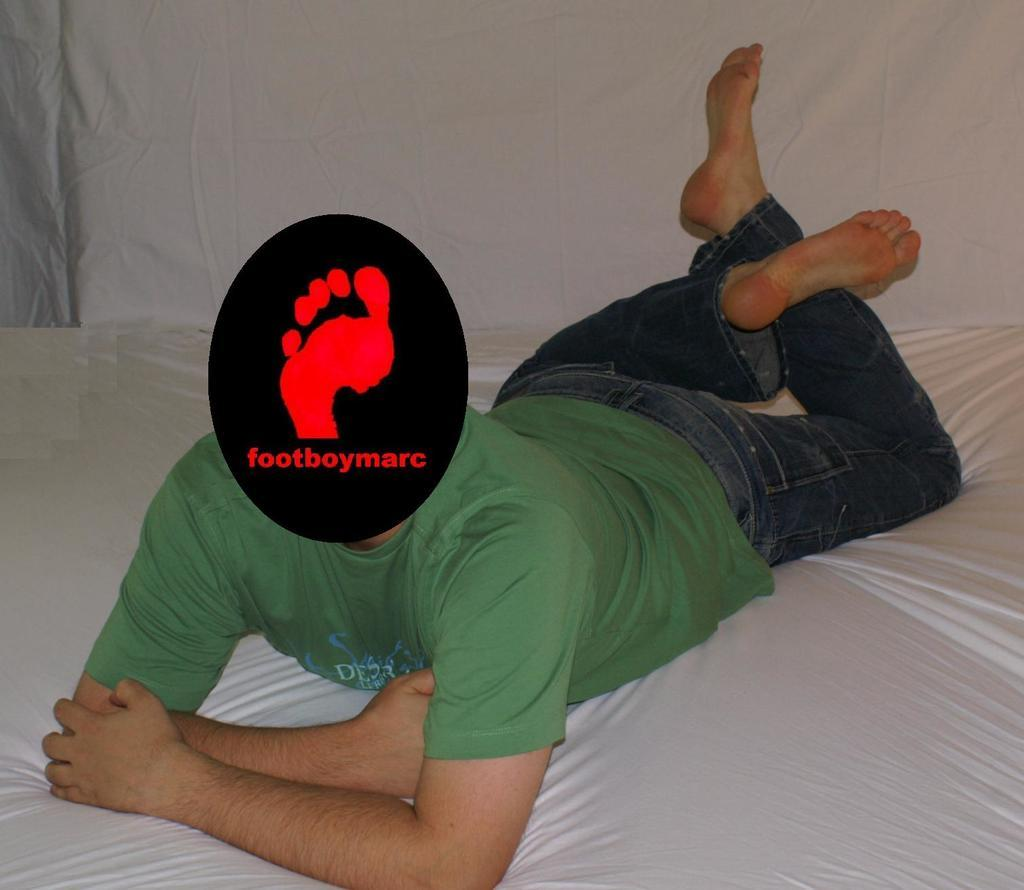Who is present in the image? There is a man in the image. What is the man wearing on his head? The man is wearing a black cap. Where is the man located in the image? The man is on a bed. What can be seen in addition to the man in the image? There is text in the image. Can you describe any unique features of the man's cap? There is a footprint on the cap. What type of home does the jellyfish live in within the image? There is no jellyfish present in the image, so it is not possible to determine the type of home it might live in. 